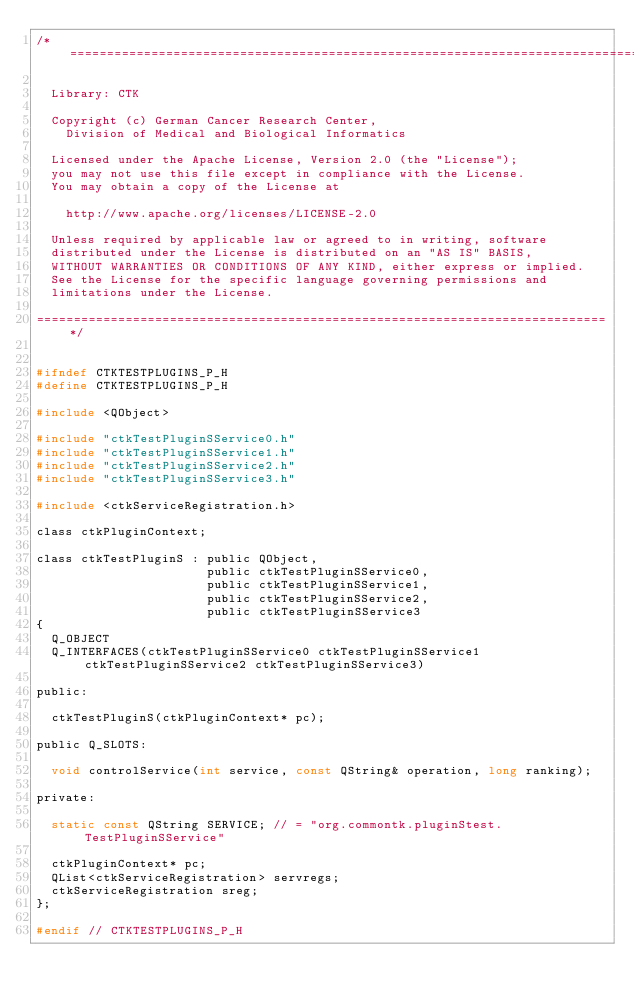Convert code to text. <code><loc_0><loc_0><loc_500><loc_500><_C_>/*=============================================================================

  Library: CTK

  Copyright (c) German Cancer Research Center,
    Division of Medical and Biological Informatics

  Licensed under the Apache License, Version 2.0 (the "License");
  you may not use this file except in compliance with the License.
  You may obtain a copy of the License at

    http://www.apache.org/licenses/LICENSE-2.0

  Unless required by applicable law or agreed to in writing, software
  distributed under the License is distributed on an "AS IS" BASIS,
  WITHOUT WARRANTIES OR CONDITIONS OF ANY KIND, either express or implied.
  See the License for the specific language governing permissions and
  limitations under the License.

=============================================================================*/


#ifndef CTKTESTPLUGINS_P_H
#define CTKTESTPLUGINS_P_H

#include <QObject>

#include "ctkTestPluginSService0.h"
#include "ctkTestPluginSService1.h"
#include "ctkTestPluginSService2.h"
#include "ctkTestPluginSService3.h"

#include <ctkServiceRegistration.h>

class ctkPluginContext;

class ctkTestPluginS : public QObject,
                       public ctkTestPluginSService0,
                       public ctkTestPluginSService1,
                       public ctkTestPluginSService2,
                       public ctkTestPluginSService3
{
  Q_OBJECT
  Q_INTERFACES(ctkTestPluginSService0 ctkTestPluginSService1 ctkTestPluginSService2 ctkTestPluginSService3)

public:

  ctkTestPluginS(ctkPluginContext* pc);
  
public Q_SLOTS:

  void controlService(int service, const QString& operation, long ranking);

private:

  static const QString SERVICE; // = "org.commontk.pluginStest.TestPluginSService"

  ctkPluginContext* pc;
  QList<ctkServiceRegistration> servregs;
  ctkServiceRegistration sreg;
};

#endif // CTKTESTPLUGINS_P_H
</code> 